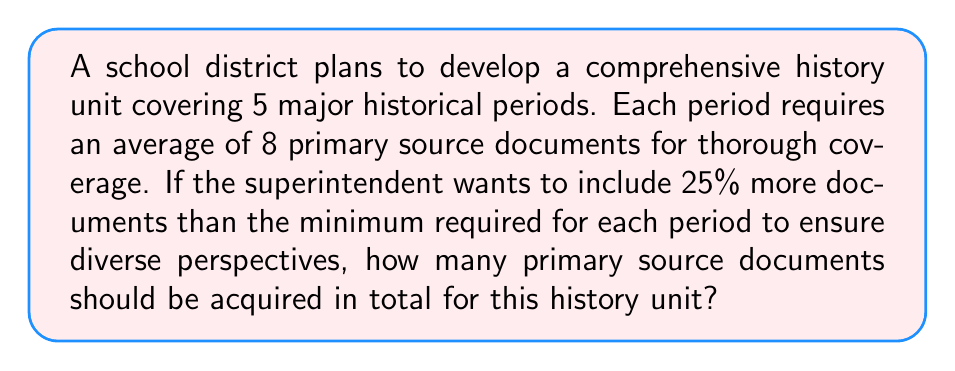Teach me how to tackle this problem. Let's break this down step-by-step:

1. Calculate the minimum number of documents needed:
   - Number of historical periods: 5
   - Average documents per period: 8
   - Minimum total: $5 \times 8 = 40$ documents

2. Calculate the additional documents (25% more):
   - 25% of 40 = $40 \times 0.25 = 10$ additional documents

3. Calculate the total number of documents:
   - Total = Minimum + Additional
   - Total = $40 + 10 = 50$ documents

Therefore, the superintendent should acquire 50 primary source documents for this comprehensive history unit.
Answer: 50 documents 